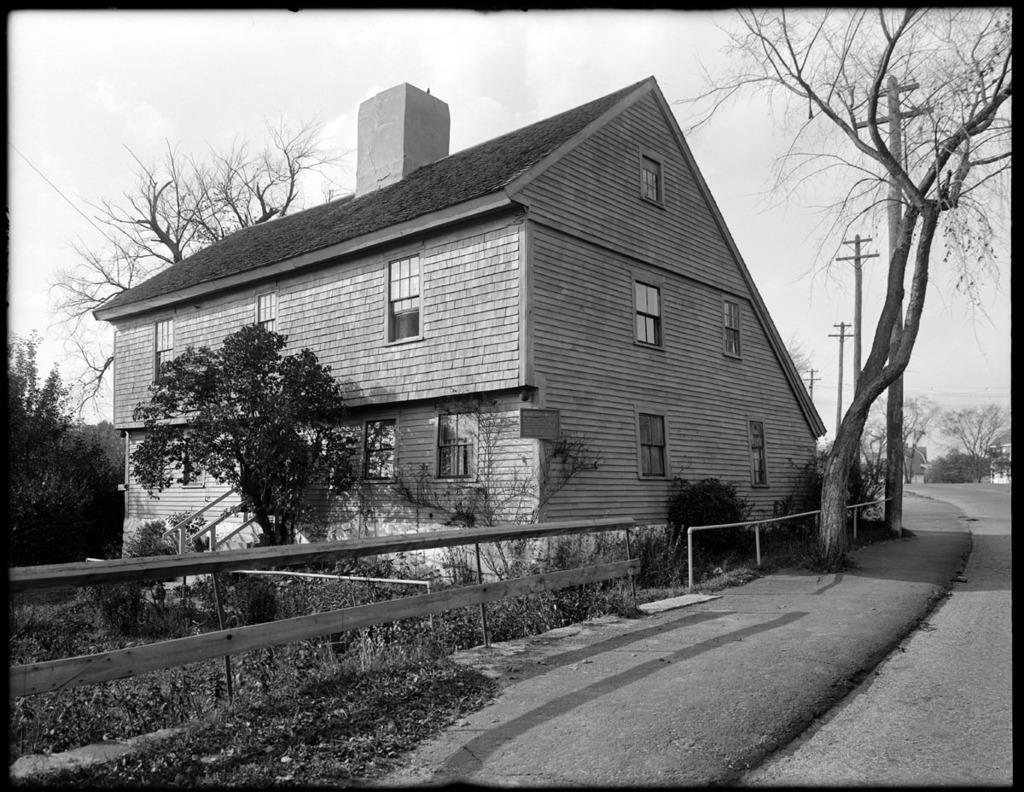What is the color scheme of the image? The image is black and white. What can be seen in the foreground of the image? There is a road, trees, electric poles, wires, plants, fences, and a house with windows in the foreground of the image. What is visible in the background of the image? Trees, houses, and the sky are visible in the background of the image. What type of government is depicted in the image? There is no depiction of a government in the image; it features a road, trees, electric poles, wires, plants, fences, a house, windows, trees in the background, houses in the background, and the sky. Can you tell me how many times the person in the image kicks the ball? There is no person or ball present in the image. 